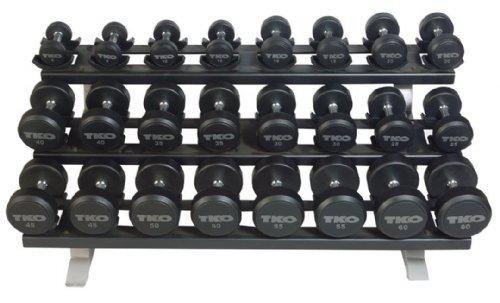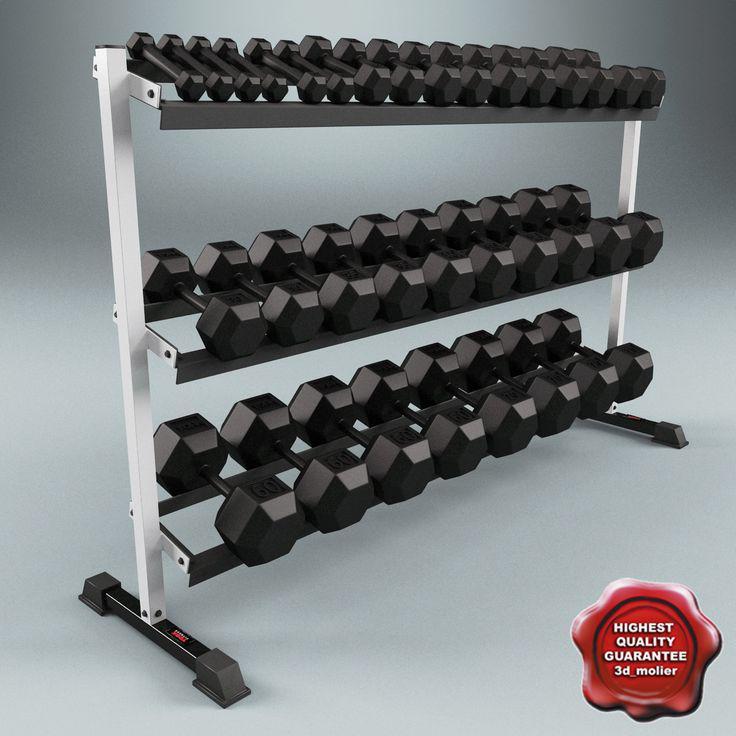The first image is the image on the left, the second image is the image on the right. Analyze the images presented: Is the assertion "The right image contains sets of weights stacked into three rows." valid? Answer yes or no. Yes. The first image is the image on the left, the second image is the image on the right. Evaluate the accuracy of this statement regarding the images: "The weights on the rack in the image on the left are round.". Is it true? Answer yes or no. Yes. 